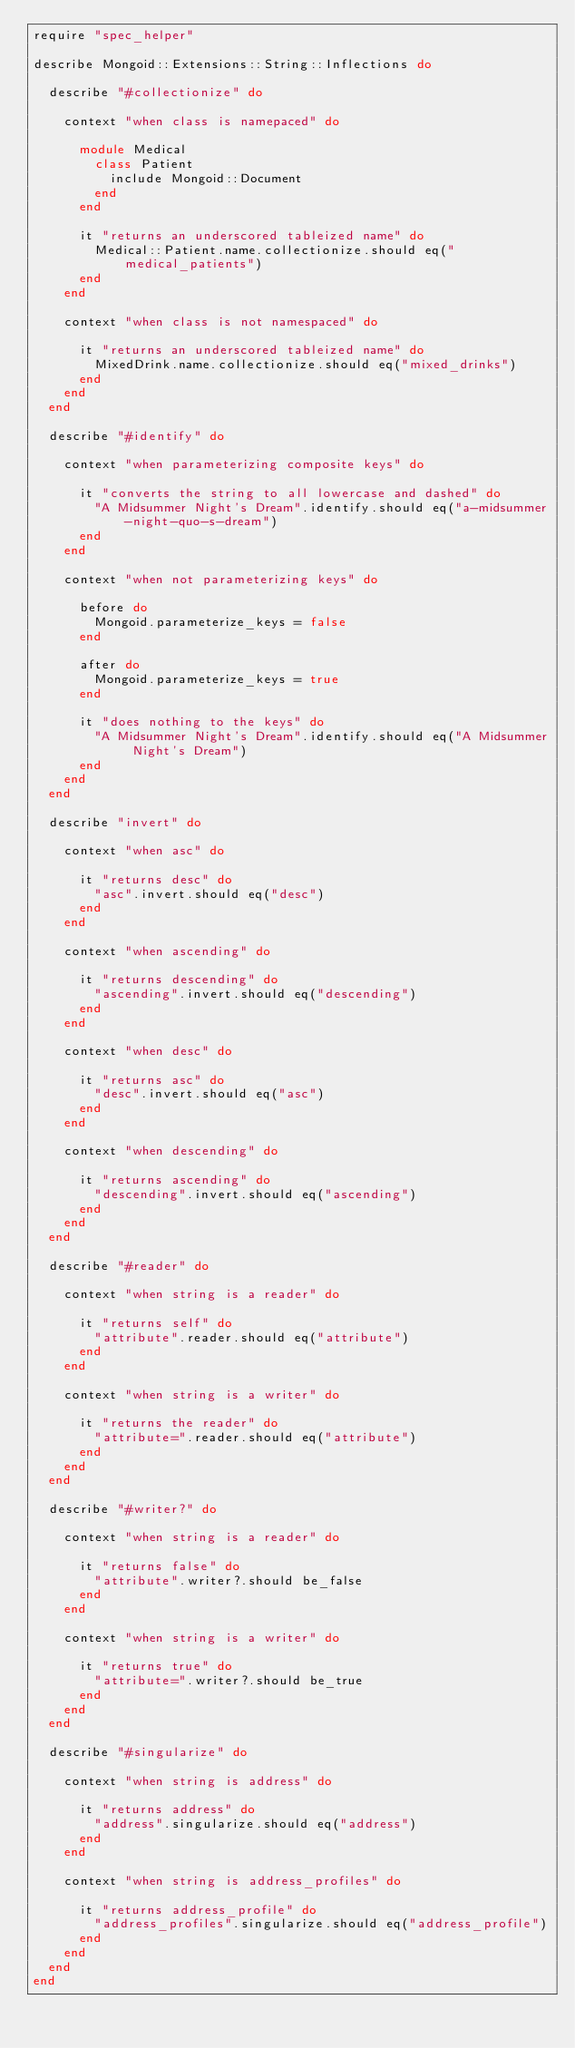<code> <loc_0><loc_0><loc_500><loc_500><_Ruby_>require "spec_helper"

describe Mongoid::Extensions::String::Inflections do

  describe "#collectionize" do

    context "when class is namepaced" do

      module Medical
        class Patient
          include Mongoid::Document
        end
      end

      it "returns an underscored tableized name" do
        Medical::Patient.name.collectionize.should eq("medical_patients")
      end
    end

    context "when class is not namespaced" do

      it "returns an underscored tableized name" do
        MixedDrink.name.collectionize.should eq("mixed_drinks")
      end
    end
  end

  describe "#identify" do

    context "when parameterizing composite keys" do

      it "converts the string to all lowercase and dashed" do
        "A Midsummer Night's Dream".identify.should eq("a-midsummer-night-quo-s-dream")
      end
    end

    context "when not parameterizing keys" do

      before do
        Mongoid.parameterize_keys = false
      end

      after do
        Mongoid.parameterize_keys = true
      end

      it "does nothing to the keys" do
        "A Midsummer Night's Dream".identify.should eq("A Midsummer Night's Dream")
      end
    end
  end

  describe "invert" do

    context "when asc" do

      it "returns desc" do
        "asc".invert.should eq("desc")
      end
    end

    context "when ascending" do

      it "returns descending" do
        "ascending".invert.should eq("descending")
      end
    end

    context "when desc" do

      it "returns asc" do
        "desc".invert.should eq("asc")
      end
    end

    context "when descending" do

      it "returns ascending" do
        "descending".invert.should eq("ascending")
      end
    end
  end

  describe "#reader" do

    context "when string is a reader" do

      it "returns self" do
        "attribute".reader.should eq("attribute")
      end
    end

    context "when string is a writer" do

      it "returns the reader" do
        "attribute=".reader.should eq("attribute")
      end
    end
  end

  describe "#writer?" do

    context "when string is a reader" do

      it "returns false" do
        "attribute".writer?.should be_false
      end
    end

    context "when string is a writer" do

      it "returns true" do
        "attribute=".writer?.should be_true
      end
    end
  end

  describe "#singularize" do

    context "when string is address" do

      it "returns address" do
        "address".singularize.should eq("address")
      end
    end

    context "when string is address_profiles" do

      it "returns address_profile" do
        "address_profiles".singularize.should eq("address_profile")
      end
    end
  end
end
</code> 